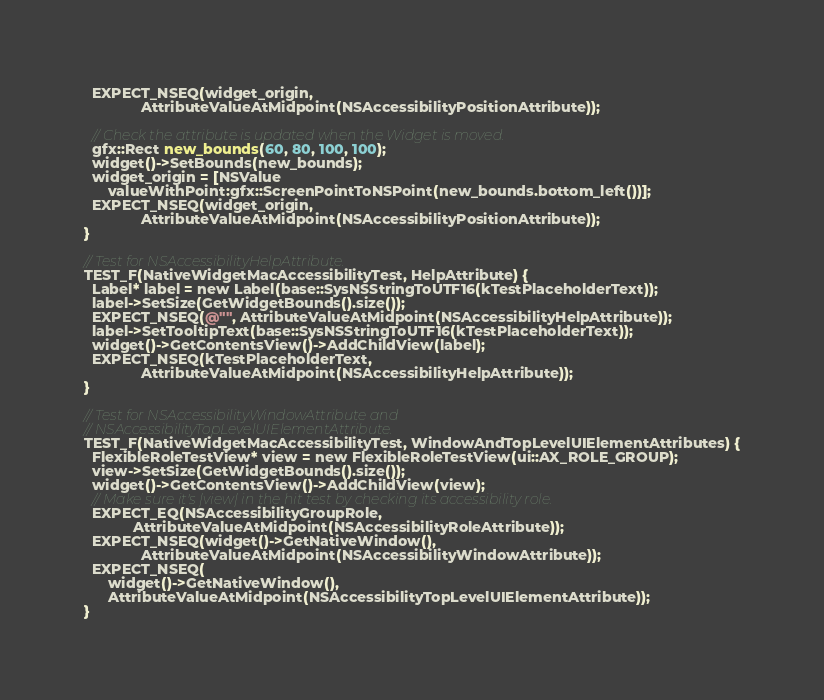<code> <loc_0><loc_0><loc_500><loc_500><_ObjectiveC_>  EXPECT_NSEQ(widget_origin,
              AttributeValueAtMidpoint(NSAccessibilityPositionAttribute));

  // Check the attribute is updated when the Widget is moved.
  gfx::Rect new_bounds(60, 80, 100, 100);
  widget()->SetBounds(new_bounds);
  widget_origin = [NSValue
      valueWithPoint:gfx::ScreenPointToNSPoint(new_bounds.bottom_left())];
  EXPECT_NSEQ(widget_origin,
              AttributeValueAtMidpoint(NSAccessibilityPositionAttribute));
}

// Test for NSAccessibilityHelpAttribute.
TEST_F(NativeWidgetMacAccessibilityTest, HelpAttribute) {
  Label* label = new Label(base::SysNSStringToUTF16(kTestPlaceholderText));
  label->SetSize(GetWidgetBounds().size());
  EXPECT_NSEQ(@"", AttributeValueAtMidpoint(NSAccessibilityHelpAttribute));
  label->SetTooltipText(base::SysNSStringToUTF16(kTestPlaceholderText));
  widget()->GetContentsView()->AddChildView(label);
  EXPECT_NSEQ(kTestPlaceholderText,
              AttributeValueAtMidpoint(NSAccessibilityHelpAttribute));
}

// Test for NSAccessibilityWindowAttribute and
// NSAccessibilityTopLevelUIElementAttribute.
TEST_F(NativeWidgetMacAccessibilityTest, WindowAndTopLevelUIElementAttributes) {
  FlexibleRoleTestView* view = new FlexibleRoleTestView(ui::AX_ROLE_GROUP);
  view->SetSize(GetWidgetBounds().size());
  widget()->GetContentsView()->AddChildView(view);
  // Make sure it's |view| in the hit test by checking its accessibility role.
  EXPECT_EQ(NSAccessibilityGroupRole,
            AttributeValueAtMidpoint(NSAccessibilityRoleAttribute));
  EXPECT_NSEQ(widget()->GetNativeWindow(),
              AttributeValueAtMidpoint(NSAccessibilityWindowAttribute));
  EXPECT_NSEQ(
      widget()->GetNativeWindow(),
      AttributeValueAtMidpoint(NSAccessibilityTopLevelUIElementAttribute));
}
</code> 